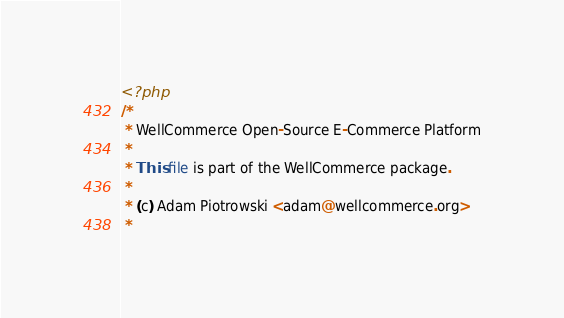<code> <loc_0><loc_0><loc_500><loc_500><_PHP_><?php
/*
 * WellCommerce Open-Source E-Commerce Platform
 * 
 * This file is part of the WellCommerce package.
 *
 * (c) Adam Piotrowski <adam@wellcommerce.org>
 * </code> 